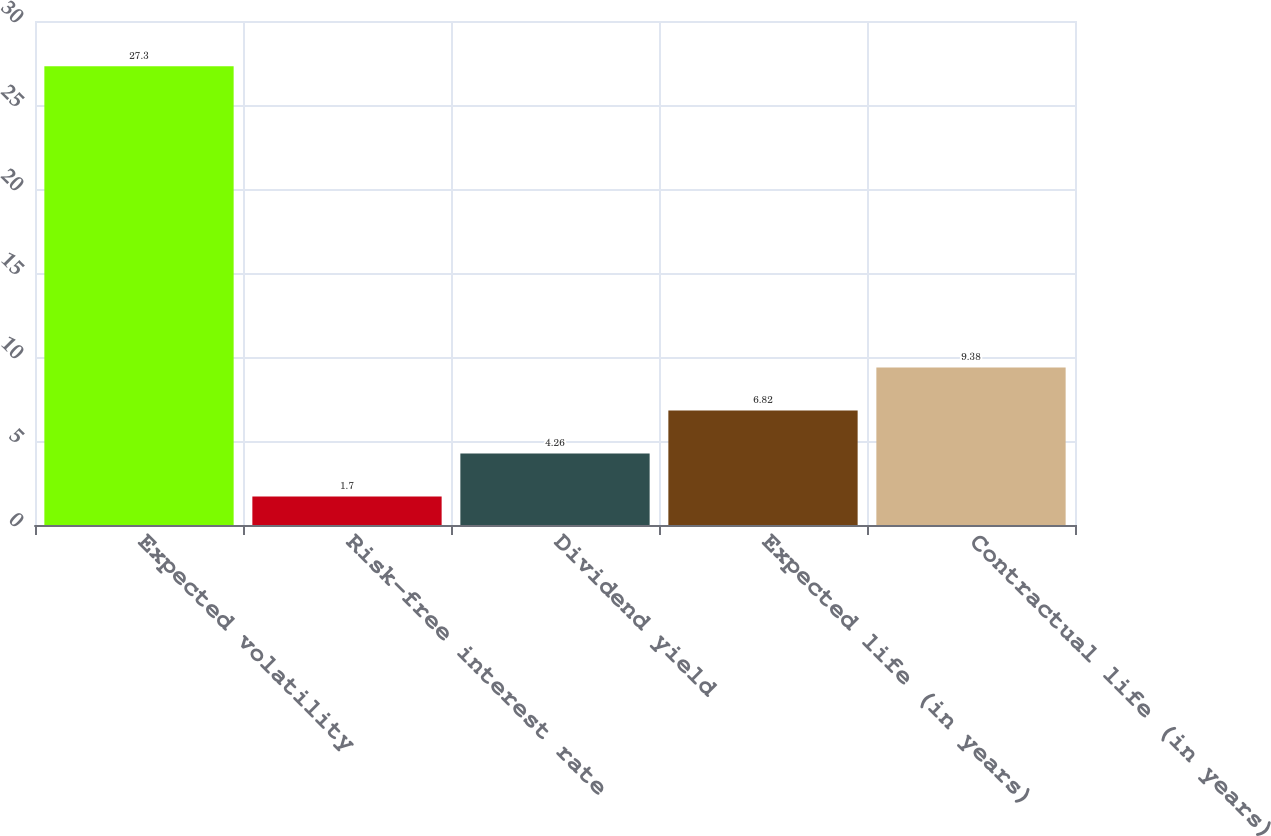Convert chart. <chart><loc_0><loc_0><loc_500><loc_500><bar_chart><fcel>Expected volatility<fcel>Risk-free interest rate<fcel>Dividend yield<fcel>Expected life (in years)<fcel>Contractual life (in years)<nl><fcel>27.3<fcel>1.7<fcel>4.26<fcel>6.82<fcel>9.38<nl></chart> 